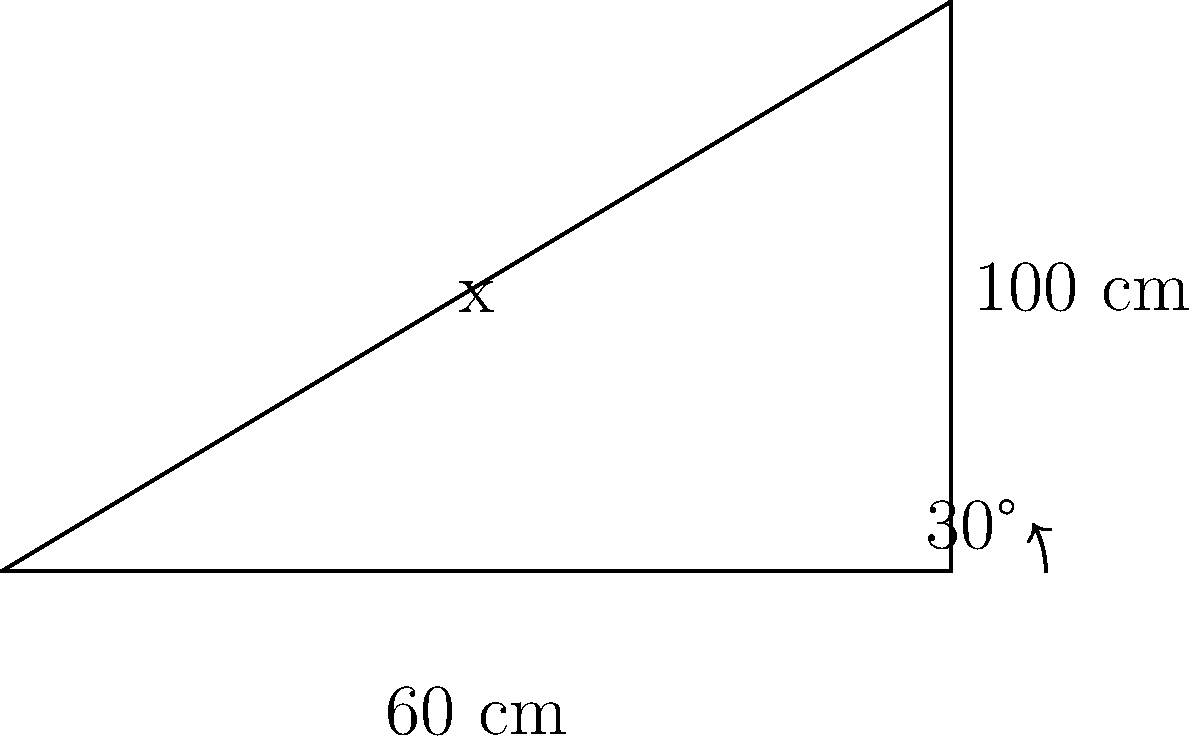You're designing a custom truck hood scoop for improved air intake efficiency. The scoop has a triangular cross-section with a base length of 100 cm and a height of 60 cm. The optimal angle for air intake is 30° from the horizontal. What is the length (x) of the scoop's angled surface in centimeters? To solve this problem, we'll use trigonometry:

1) First, we identify the triangle formed by the scoop's cross-section. We have a right triangle with:
   - Base (adjacent to the 30° angle) = 100 cm
   - Height (opposite to the 30° angle) = 60 cm
   - Hypotenuse (x) = the length we're looking for

2) We can use the tangent function to find the angle opposite to x:
   $\tan(30°) = \frac{\text{opposite}}{\text{adjacent}} = \frac{60}{100} = 0.6$

3) This confirms that the angle is indeed 30°, as given in the problem.

4) To find x (the hypotenuse), we can use the Pythagorean theorem:
   $x^2 = 100^2 + 60^2$

5) Simplify:
   $x^2 = 10000 + 3600 = 13600$

6) Take the square root of both sides:
   $x = \sqrt{13600} = 116.62$ cm

Therefore, the length of the scoop's angled surface is approximately 116.62 cm.
Answer: 116.62 cm 